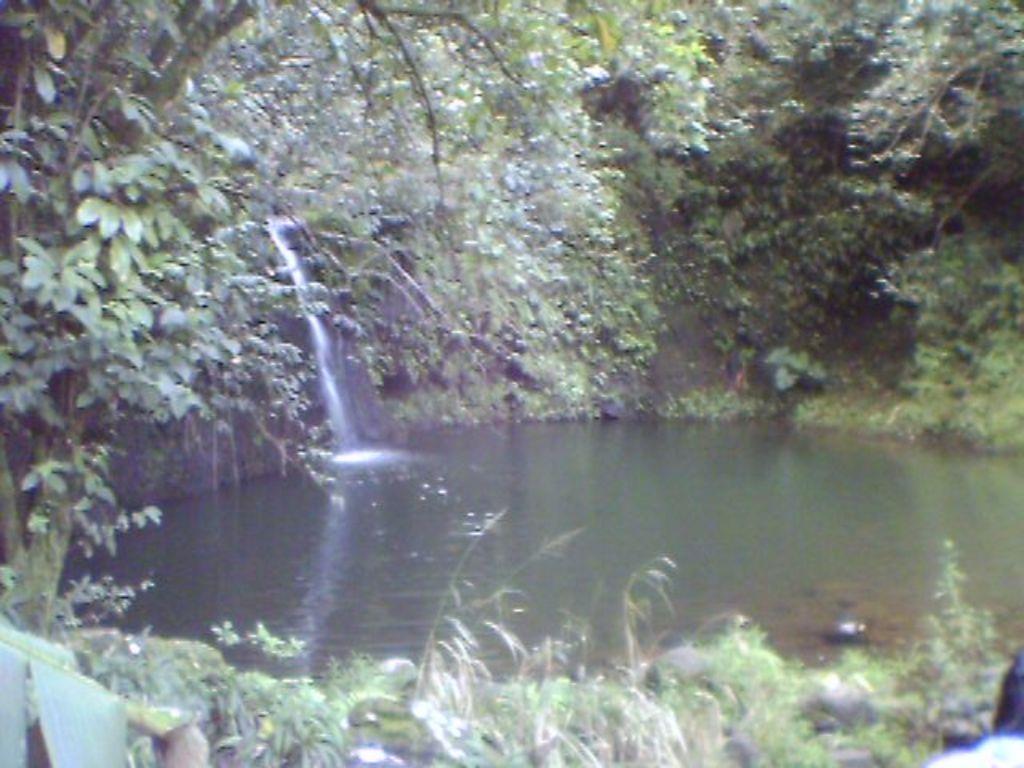Can you describe this image briefly? In this image we can see a waterfall. There is water at the bottom. In the background of the image there are trees. At the bottom of the image there is grass. 